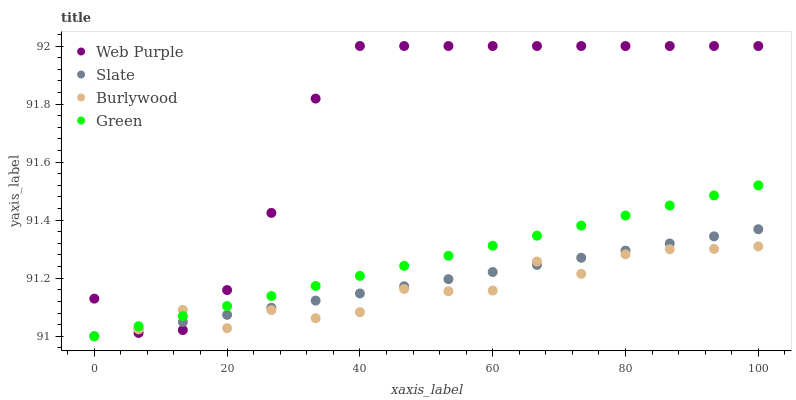Does Burlywood have the minimum area under the curve?
Answer yes or no. Yes. Does Web Purple have the maximum area under the curve?
Answer yes or no. Yes. Does Green have the minimum area under the curve?
Answer yes or no. No. Does Green have the maximum area under the curve?
Answer yes or no. No. Is Green the smoothest?
Answer yes or no. Yes. Is Burlywood the roughest?
Answer yes or no. Yes. Is Web Purple the smoothest?
Answer yes or no. No. Is Web Purple the roughest?
Answer yes or no. No. Does Burlywood have the lowest value?
Answer yes or no. Yes. Does Web Purple have the lowest value?
Answer yes or no. No. Does Web Purple have the highest value?
Answer yes or no. Yes. Does Green have the highest value?
Answer yes or no. No. Does Green intersect Slate?
Answer yes or no. Yes. Is Green less than Slate?
Answer yes or no. No. Is Green greater than Slate?
Answer yes or no. No. 